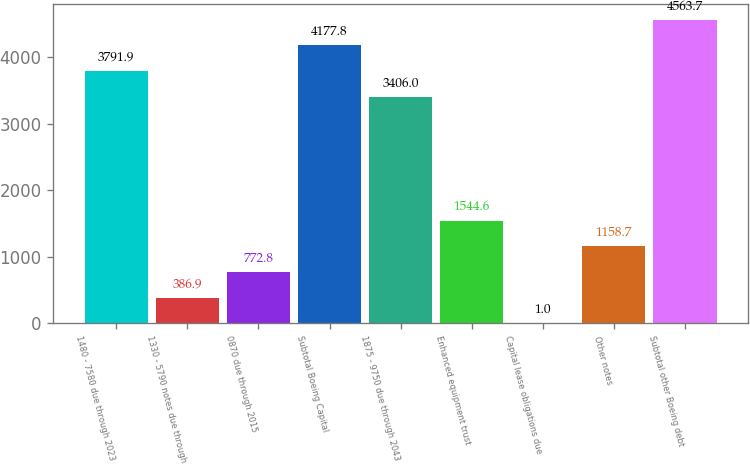<chart> <loc_0><loc_0><loc_500><loc_500><bar_chart><fcel>1480 - 7580 due through 2023<fcel>1330 - 5790 notes due through<fcel>0870 due through 2015<fcel>Subtotal Boeing Capital<fcel>1875 - 9750 due through 2043<fcel>Enhanced equipment trust<fcel>Capital lease obligations due<fcel>Other notes<fcel>Subtotal other Boeing debt<nl><fcel>3791.9<fcel>386.9<fcel>772.8<fcel>4177.8<fcel>3406<fcel>1544.6<fcel>1<fcel>1158.7<fcel>4563.7<nl></chart> 